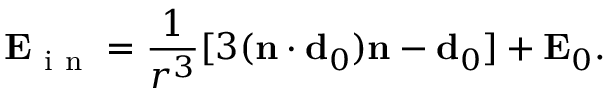<formula> <loc_0><loc_0><loc_500><loc_500>E _ { i n } = \frac { 1 } { r ^ { 3 } } [ 3 ( n \cdot d _ { 0 } ) n - d _ { 0 } ] + E _ { 0 } .</formula> 